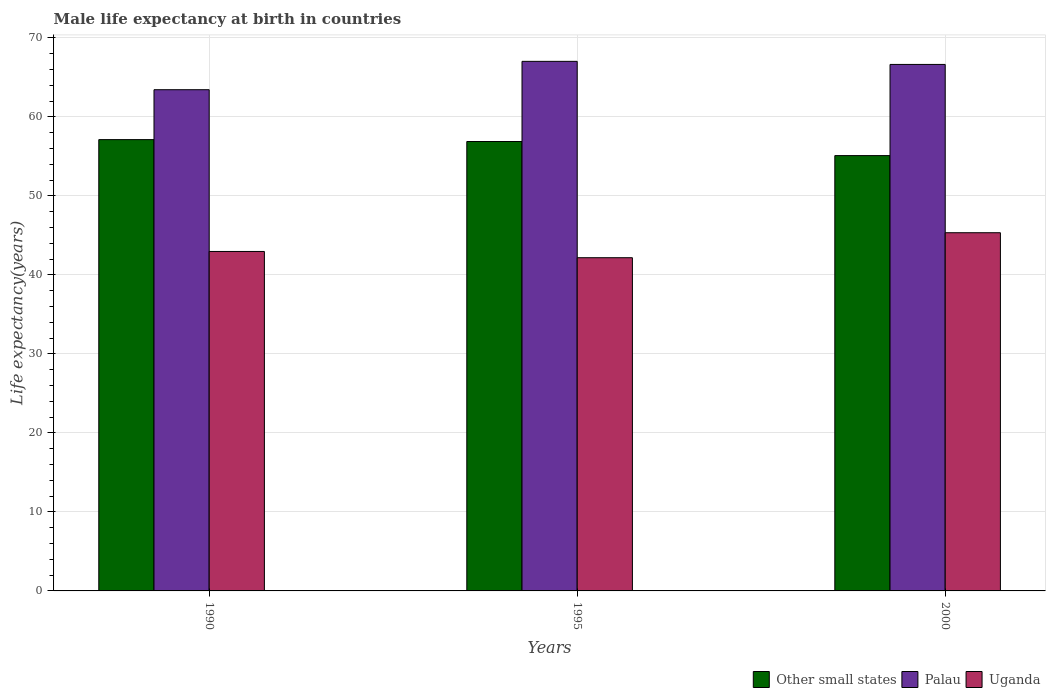How many bars are there on the 2nd tick from the left?
Your response must be concise. 3. How many bars are there on the 3rd tick from the right?
Ensure brevity in your answer.  3. What is the label of the 3rd group of bars from the left?
Keep it short and to the point. 2000. In how many cases, is the number of bars for a given year not equal to the number of legend labels?
Your answer should be compact. 0. What is the male life expectancy at birth in Other small states in 1990?
Your answer should be very brief. 57.12. Across all years, what is the maximum male life expectancy at birth in Uganda?
Your response must be concise. 45.34. Across all years, what is the minimum male life expectancy at birth in Uganda?
Your response must be concise. 42.18. In which year was the male life expectancy at birth in Other small states minimum?
Make the answer very short. 2000. What is the total male life expectancy at birth in Uganda in the graph?
Give a very brief answer. 130.48. What is the difference between the male life expectancy at birth in Palau in 1990 and that in 2000?
Offer a terse response. -3.2. What is the difference between the male life expectancy at birth in Uganda in 1995 and the male life expectancy at birth in Other small states in 1990?
Keep it short and to the point. -14.95. What is the average male life expectancy at birth in Uganda per year?
Provide a succinct answer. 43.49. In the year 2000, what is the difference between the male life expectancy at birth in Other small states and male life expectancy at birth in Uganda?
Offer a terse response. 9.76. What is the ratio of the male life expectancy at birth in Palau in 1990 to that in 1995?
Your response must be concise. 0.95. Is the difference between the male life expectancy at birth in Other small states in 1995 and 2000 greater than the difference between the male life expectancy at birth in Uganda in 1995 and 2000?
Ensure brevity in your answer.  Yes. What is the difference between the highest and the second highest male life expectancy at birth in Other small states?
Your answer should be compact. 0.24. What is the difference between the highest and the lowest male life expectancy at birth in Uganda?
Make the answer very short. 3.16. What does the 1st bar from the left in 2000 represents?
Give a very brief answer. Other small states. What does the 1st bar from the right in 2000 represents?
Your answer should be compact. Uganda. Is it the case that in every year, the sum of the male life expectancy at birth in Palau and male life expectancy at birth in Other small states is greater than the male life expectancy at birth in Uganda?
Your response must be concise. Yes. How many bars are there?
Provide a succinct answer. 9. Are all the bars in the graph horizontal?
Make the answer very short. No. How many years are there in the graph?
Provide a short and direct response. 3. What is the difference between two consecutive major ticks on the Y-axis?
Your answer should be very brief. 10. Are the values on the major ticks of Y-axis written in scientific E-notation?
Provide a succinct answer. No. Where does the legend appear in the graph?
Your answer should be compact. Bottom right. What is the title of the graph?
Your answer should be compact. Male life expectancy at birth in countries. What is the label or title of the X-axis?
Provide a short and direct response. Years. What is the label or title of the Y-axis?
Ensure brevity in your answer.  Life expectancy(years). What is the Life expectancy(years) of Other small states in 1990?
Provide a short and direct response. 57.12. What is the Life expectancy(years) of Palau in 1990?
Offer a very short reply. 63.44. What is the Life expectancy(years) in Uganda in 1990?
Provide a short and direct response. 42.97. What is the Life expectancy(years) in Other small states in 1995?
Provide a succinct answer. 56.88. What is the Life expectancy(years) in Palau in 1995?
Give a very brief answer. 67.03. What is the Life expectancy(years) in Uganda in 1995?
Make the answer very short. 42.18. What is the Life expectancy(years) in Other small states in 2000?
Your response must be concise. 55.1. What is the Life expectancy(years) in Palau in 2000?
Make the answer very short. 66.64. What is the Life expectancy(years) of Uganda in 2000?
Provide a succinct answer. 45.34. Across all years, what is the maximum Life expectancy(years) in Other small states?
Give a very brief answer. 57.12. Across all years, what is the maximum Life expectancy(years) in Palau?
Provide a succinct answer. 67.03. Across all years, what is the maximum Life expectancy(years) in Uganda?
Your answer should be compact. 45.34. Across all years, what is the minimum Life expectancy(years) in Other small states?
Give a very brief answer. 55.1. Across all years, what is the minimum Life expectancy(years) of Palau?
Your response must be concise. 63.44. Across all years, what is the minimum Life expectancy(years) in Uganda?
Keep it short and to the point. 42.18. What is the total Life expectancy(years) in Other small states in the graph?
Provide a short and direct response. 169.11. What is the total Life expectancy(years) in Palau in the graph?
Keep it short and to the point. 197.11. What is the total Life expectancy(years) in Uganda in the graph?
Make the answer very short. 130.48. What is the difference between the Life expectancy(years) in Other small states in 1990 and that in 1995?
Offer a very short reply. 0.24. What is the difference between the Life expectancy(years) in Palau in 1990 and that in 1995?
Keep it short and to the point. -3.59. What is the difference between the Life expectancy(years) in Uganda in 1990 and that in 1995?
Give a very brief answer. 0.79. What is the difference between the Life expectancy(years) of Other small states in 1990 and that in 2000?
Offer a very short reply. 2.02. What is the difference between the Life expectancy(years) of Palau in 1990 and that in 2000?
Make the answer very short. -3.2. What is the difference between the Life expectancy(years) in Uganda in 1990 and that in 2000?
Give a very brief answer. -2.37. What is the difference between the Life expectancy(years) of Other small states in 1995 and that in 2000?
Ensure brevity in your answer.  1.78. What is the difference between the Life expectancy(years) of Palau in 1995 and that in 2000?
Offer a terse response. 0.39. What is the difference between the Life expectancy(years) of Uganda in 1995 and that in 2000?
Offer a very short reply. -3.16. What is the difference between the Life expectancy(years) of Other small states in 1990 and the Life expectancy(years) of Palau in 1995?
Keep it short and to the point. -9.91. What is the difference between the Life expectancy(years) in Other small states in 1990 and the Life expectancy(years) in Uganda in 1995?
Make the answer very short. 14.95. What is the difference between the Life expectancy(years) of Palau in 1990 and the Life expectancy(years) of Uganda in 1995?
Provide a short and direct response. 21.26. What is the difference between the Life expectancy(years) in Other small states in 1990 and the Life expectancy(years) in Palau in 2000?
Your answer should be compact. -9.52. What is the difference between the Life expectancy(years) of Other small states in 1990 and the Life expectancy(years) of Uganda in 2000?
Offer a terse response. 11.78. What is the difference between the Life expectancy(years) in Palau in 1990 and the Life expectancy(years) in Uganda in 2000?
Offer a very short reply. 18.1. What is the difference between the Life expectancy(years) of Other small states in 1995 and the Life expectancy(years) of Palau in 2000?
Your response must be concise. -9.76. What is the difference between the Life expectancy(years) in Other small states in 1995 and the Life expectancy(years) in Uganda in 2000?
Your response must be concise. 11.55. What is the difference between the Life expectancy(years) of Palau in 1995 and the Life expectancy(years) of Uganda in 2000?
Provide a short and direct response. 21.69. What is the average Life expectancy(years) of Other small states per year?
Your answer should be compact. 56.37. What is the average Life expectancy(years) of Palau per year?
Offer a terse response. 65.7. What is the average Life expectancy(years) in Uganda per year?
Provide a short and direct response. 43.49. In the year 1990, what is the difference between the Life expectancy(years) in Other small states and Life expectancy(years) in Palau?
Ensure brevity in your answer.  -6.32. In the year 1990, what is the difference between the Life expectancy(years) in Other small states and Life expectancy(years) in Uganda?
Keep it short and to the point. 14.16. In the year 1990, what is the difference between the Life expectancy(years) in Palau and Life expectancy(years) in Uganda?
Provide a succinct answer. 20.47. In the year 1995, what is the difference between the Life expectancy(years) in Other small states and Life expectancy(years) in Palau?
Ensure brevity in your answer.  -10.15. In the year 1995, what is the difference between the Life expectancy(years) in Other small states and Life expectancy(years) in Uganda?
Give a very brief answer. 14.71. In the year 1995, what is the difference between the Life expectancy(years) of Palau and Life expectancy(years) of Uganda?
Keep it short and to the point. 24.85. In the year 2000, what is the difference between the Life expectancy(years) of Other small states and Life expectancy(years) of Palau?
Offer a very short reply. -11.54. In the year 2000, what is the difference between the Life expectancy(years) of Other small states and Life expectancy(years) of Uganda?
Make the answer very short. 9.76. In the year 2000, what is the difference between the Life expectancy(years) of Palau and Life expectancy(years) of Uganda?
Give a very brief answer. 21.3. What is the ratio of the Life expectancy(years) in Other small states in 1990 to that in 1995?
Provide a short and direct response. 1. What is the ratio of the Life expectancy(years) in Palau in 1990 to that in 1995?
Offer a very short reply. 0.95. What is the ratio of the Life expectancy(years) of Uganda in 1990 to that in 1995?
Offer a very short reply. 1.02. What is the ratio of the Life expectancy(years) in Other small states in 1990 to that in 2000?
Your response must be concise. 1.04. What is the ratio of the Life expectancy(years) of Uganda in 1990 to that in 2000?
Offer a terse response. 0.95. What is the ratio of the Life expectancy(years) in Other small states in 1995 to that in 2000?
Provide a succinct answer. 1.03. What is the ratio of the Life expectancy(years) of Palau in 1995 to that in 2000?
Your answer should be compact. 1.01. What is the ratio of the Life expectancy(years) of Uganda in 1995 to that in 2000?
Provide a succinct answer. 0.93. What is the difference between the highest and the second highest Life expectancy(years) of Other small states?
Make the answer very short. 0.24. What is the difference between the highest and the second highest Life expectancy(years) in Palau?
Give a very brief answer. 0.39. What is the difference between the highest and the second highest Life expectancy(years) in Uganda?
Give a very brief answer. 2.37. What is the difference between the highest and the lowest Life expectancy(years) of Other small states?
Provide a succinct answer. 2.02. What is the difference between the highest and the lowest Life expectancy(years) of Palau?
Your answer should be very brief. 3.59. What is the difference between the highest and the lowest Life expectancy(years) of Uganda?
Your answer should be very brief. 3.16. 